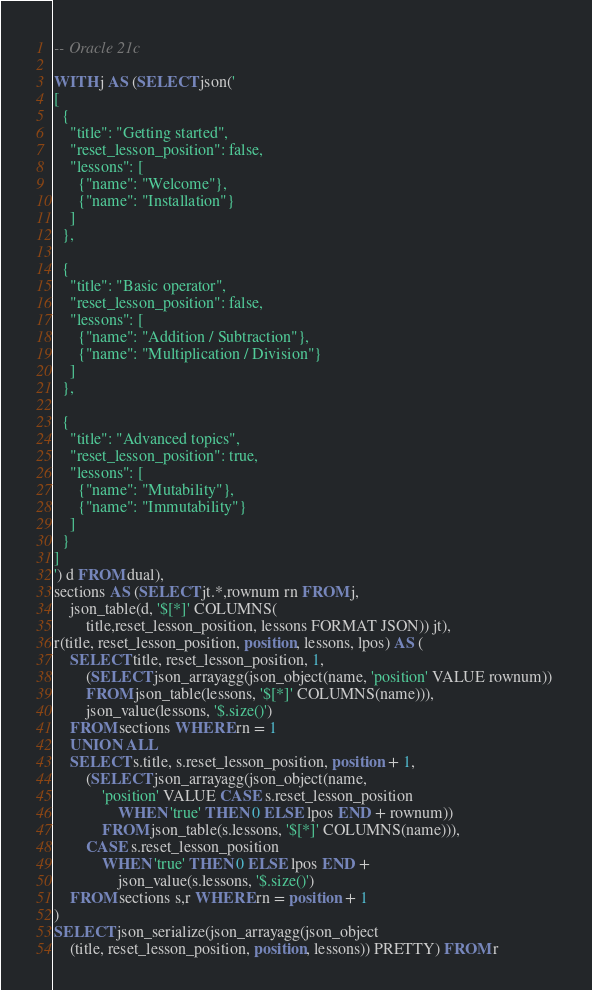<code> <loc_0><loc_0><loc_500><loc_500><_SQL_>-- Oracle 21c

WITH j AS (SELECT json('
[
  {
    "title": "Getting started",
    "reset_lesson_position": false,
    "lessons": [
      {"name": "Welcome"},
      {"name": "Installation"}
    ]
  },

  {
    "title": "Basic operator",
    "reset_lesson_position": false,
    "lessons": [
      {"name": "Addition / Subtraction"},
      {"name": "Multiplication / Division"}
    ]
  },

  {
    "title": "Advanced topics",
    "reset_lesson_position": true,
    "lessons": [
      {"name": "Mutability"},
      {"name": "Immutability"}
    ]
  }
]
') d FROM dual),
sections AS (SELECT jt.*,rownum rn FROM j,
	json_table(d, '$[*]' COLUMNS(
		title,reset_lesson_position, lessons FORMAT JSON)) jt),
r(title, reset_lesson_position, position, lessons, lpos) AS (
	SELECT title, reset_lesson_position, 1, 
		(SELECT json_arrayagg(json_object(name, 'position' VALUE rownum)) 
		FROM json_table(lessons, '$[*]' COLUMNS(name))),
		json_value(lessons, '$.size()')
	FROM sections WHERE rn = 1
	UNION ALL
	SELECT s.title, s.reset_lesson_position, position + 1, 
		(SELECT json_arrayagg(json_object(name, 
			'position' VALUE CASE s.reset_lesson_position 
				WHEN 'true' THEN 0 ELSE lpos END + rownum)) 
			FROM json_table(s.lessons, '$[*]' COLUMNS(name))),
		CASE s.reset_lesson_position 
			WHEN 'true' THEN 0 ELSE lpos END + 
				json_value(s.lessons, '$.size()')
	FROM sections s,r WHERE rn = position + 1
)
SELECT json_serialize(json_arrayagg(json_object
	(title, reset_lesson_position, position, lessons)) PRETTY) FROM r</code> 